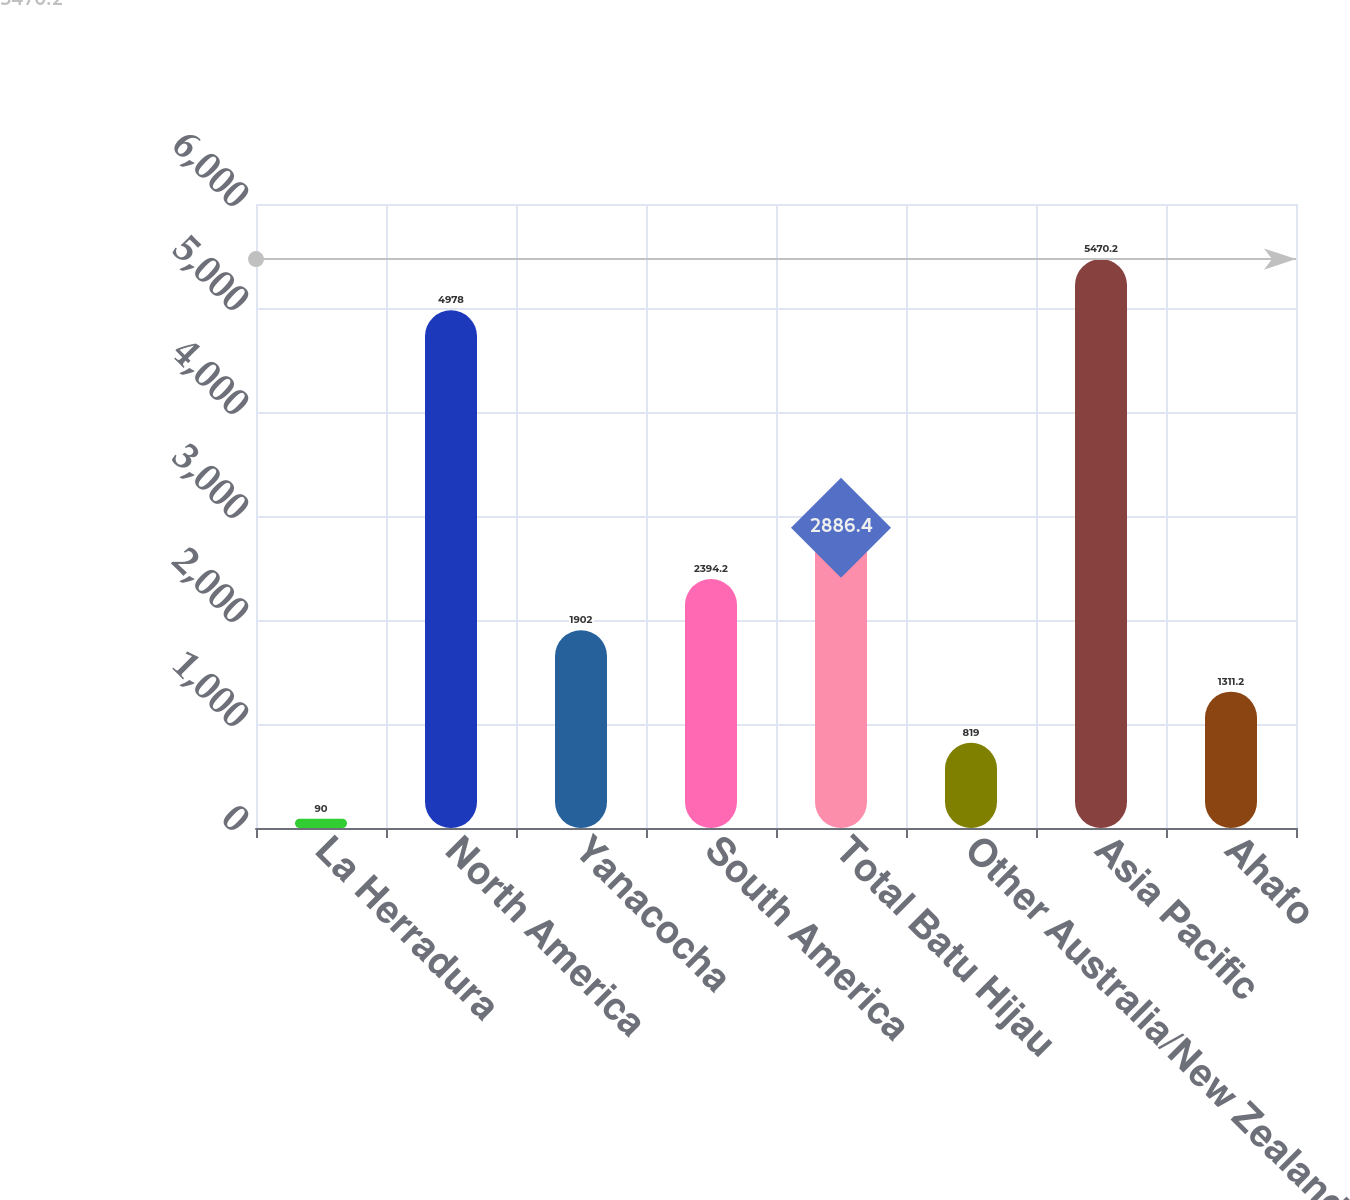Convert chart. <chart><loc_0><loc_0><loc_500><loc_500><bar_chart><fcel>La Herradura<fcel>North America<fcel>Yanacocha<fcel>South America<fcel>Total Batu Hijau<fcel>Other Australia/New Zealand<fcel>Asia Pacific<fcel>Ahafo<nl><fcel>90<fcel>4978<fcel>1902<fcel>2394.2<fcel>2886.4<fcel>819<fcel>5470.2<fcel>1311.2<nl></chart> 